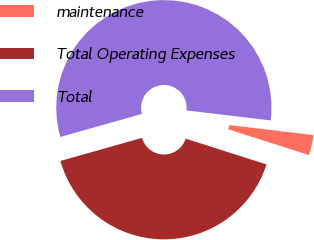Convert chart. <chart><loc_0><loc_0><loc_500><loc_500><pie_chart><fcel>maintenance<fcel>Total Operating Expenses<fcel>Total<nl><fcel>3.03%<fcel>40.71%<fcel>56.26%<nl></chart> 